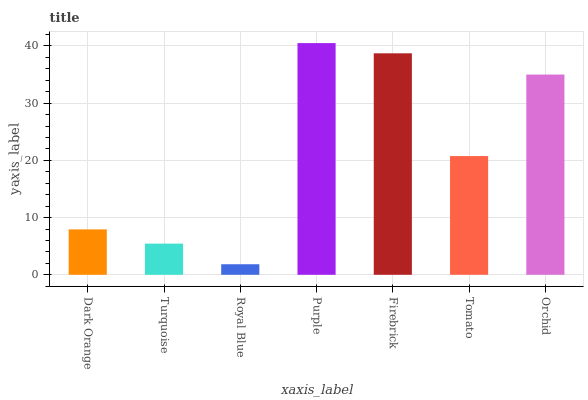Is Royal Blue the minimum?
Answer yes or no. Yes. Is Purple the maximum?
Answer yes or no. Yes. Is Turquoise the minimum?
Answer yes or no. No. Is Turquoise the maximum?
Answer yes or no. No. Is Dark Orange greater than Turquoise?
Answer yes or no. Yes. Is Turquoise less than Dark Orange?
Answer yes or no. Yes. Is Turquoise greater than Dark Orange?
Answer yes or no. No. Is Dark Orange less than Turquoise?
Answer yes or no. No. Is Tomato the high median?
Answer yes or no. Yes. Is Tomato the low median?
Answer yes or no. Yes. Is Turquoise the high median?
Answer yes or no. No. Is Firebrick the low median?
Answer yes or no. No. 